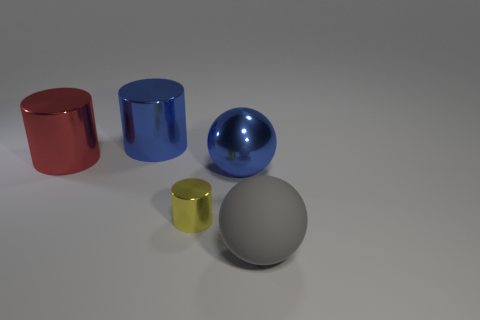What material is the thing that is the same color as the shiny ball?
Give a very brief answer. Metal. There is a sphere to the right of the large ball that is on the left side of the matte thing; are there any yellow metallic cylinders in front of it?
Offer a terse response. No. Are the sphere that is on the left side of the large rubber thing and the cylinder that is in front of the big red metallic object made of the same material?
Your answer should be compact. Yes. How many things are either large blue metallic objects or large things behind the big gray rubber thing?
Give a very brief answer. 3. How many other tiny metallic objects have the same shape as the gray thing?
Make the answer very short. 0. There is a red object that is the same size as the blue sphere; what material is it?
Make the answer very short. Metal. What size is the blue thing that is in front of the blue object that is behind the large ball that is behind the large gray matte sphere?
Ensure brevity in your answer.  Large. There is a ball that is behind the big matte thing; does it have the same color as the thing that is on the left side of the big blue metal cylinder?
Offer a very short reply. No. What number of brown things are big rubber things or tiny metallic cylinders?
Give a very brief answer. 0. How many rubber spheres have the same size as the red cylinder?
Offer a very short reply. 1. 